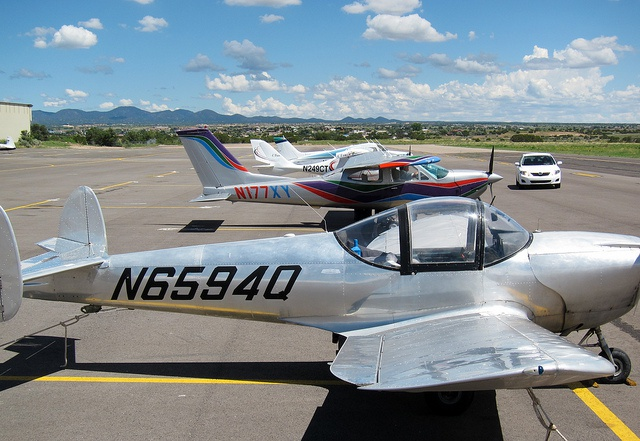Describe the objects in this image and their specific colors. I can see airplane in gray, darkgray, lightgray, and black tones, airplane in gray, black, darkgray, and lightgray tones, airplane in gray, lightgray, and darkgray tones, car in gray, white, black, and darkgray tones, and airplane in gray, lightgray, lightblue, darkgray, and black tones in this image. 